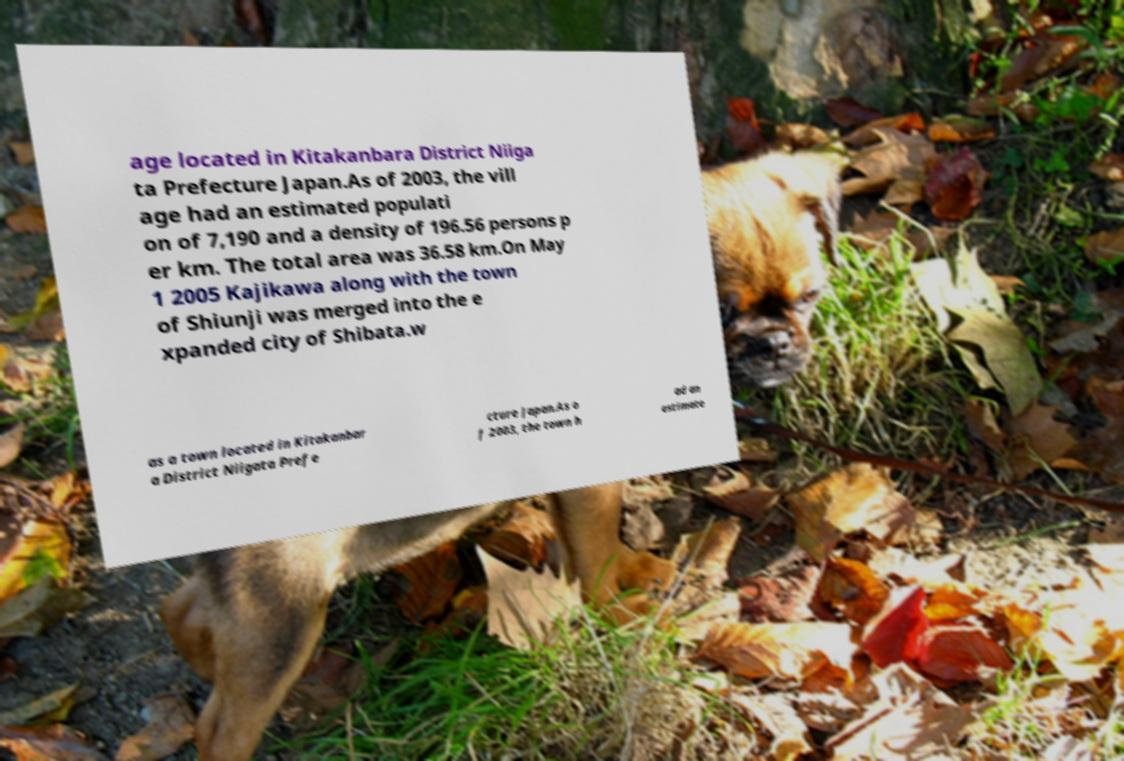Could you extract and type out the text from this image? age located in Kitakanbara District Niiga ta Prefecture Japan.As of 2003, the vill age had an estimated populati on of 7,190 and a density of 196.56 persons p er km. The total area was 36.58 km.On May 1 2005 Kajikawa along with the town of Shiunji was merged into the e xpanded city of Shibata.w as a town located in Kitakanbar a District Niigata Prefe cture Japan.As o f 2003, the town h ad an estimate 